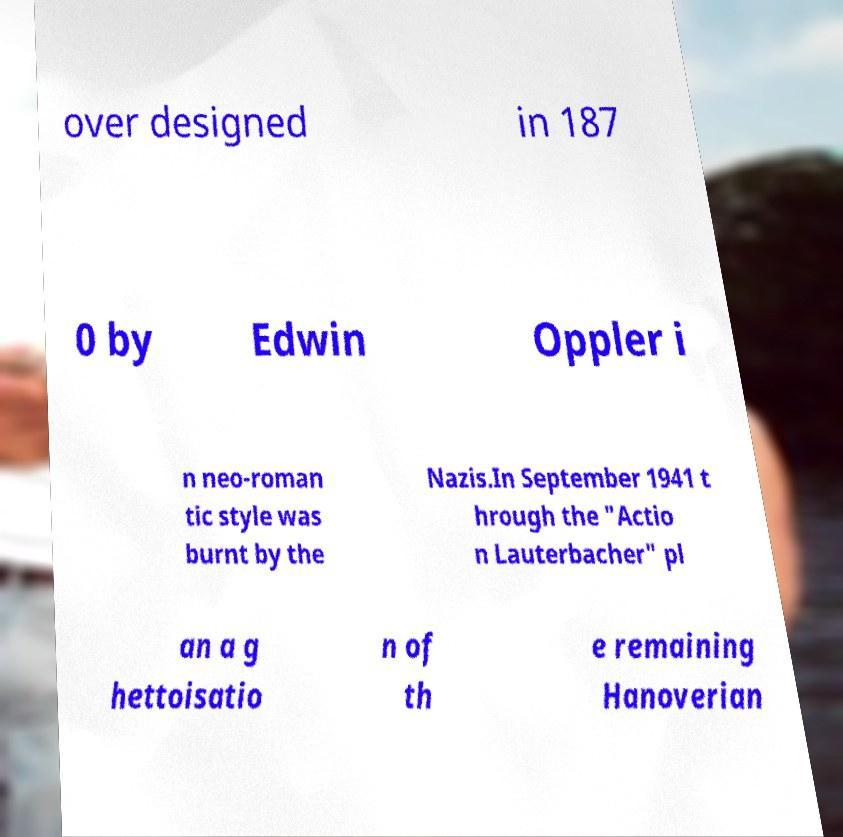Can you read and provide the text displayed in the image?This photo seems to have some interesting text. Can you extract and type it out for me? over designed in 187 0 by Edwin Oppler i n neo-roman tic style was burnt by the Nazis.In September 1941 t hrough the "Actio n Lauterbacher" pl an a g hettoisatio n of th e remaining Hanoverian 